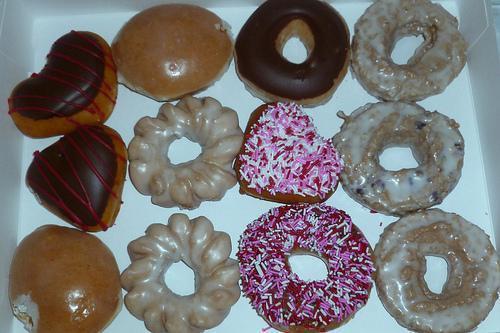How many pink ones?
Give a very brief answer. 2. How many filled doughnuts?
Give a very brief answer. 5. How many hearts?
Give a very brief answer. 3. 